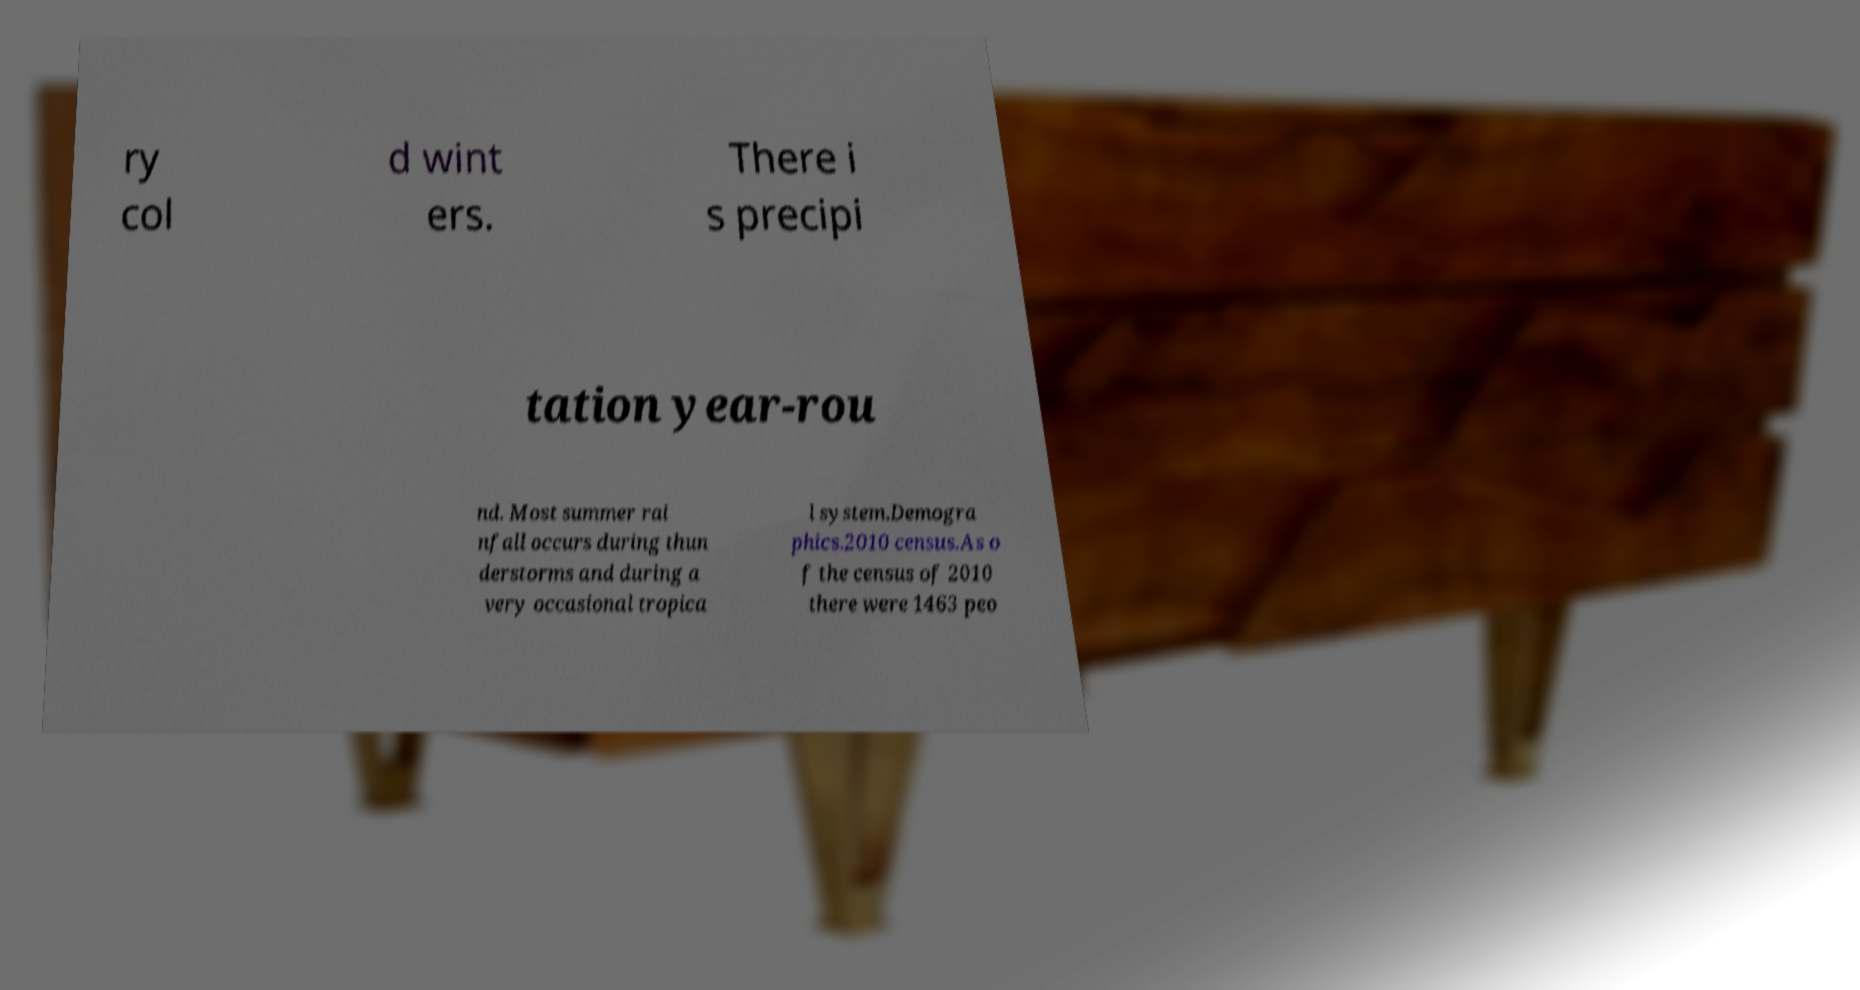I need the written content from this picture converted into text. Can you do that? ry col d wint ers. There i s precipi tation year-rou nd. Most summer rai nfall occurs during thun derstorms and during a very occasional tropica l system.Demogra phics.2010 census.As o f the census of 2010 there were 1463 peo 